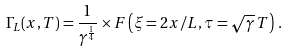<formula> <loc_0><loc_0><loc_500><loc_500>\Gamma _ { L } ( x , T ) = \frac { 1 } { \gamma ^ { \frac { 1 } { 4 } } } \times F \left ( \xi = 2 x / L , \tau = \sqrt { \gamma } \, T \right ) \, .</formula> 